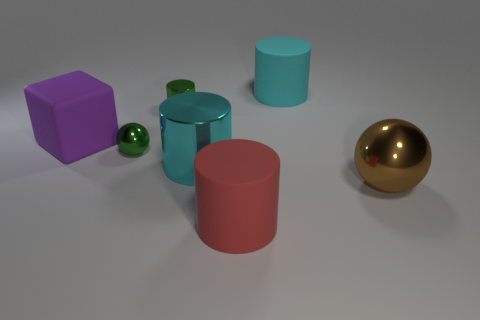There is a shiny ball that is left of the large cylinder behind the purple thing; how big is it?
Your response must be concise. Small. What is the color of the cylinder that is both behind the red thing and in front of the block?
Your answer should be very brief. Cyan. There is a red cylinder that is the same size as the matte cube; what is its material?
Make the answer very short. Rubber. What number of other objects are the same material as the big sphere?
Give a very brief answer. 3. Is the color of the small shiny thing that is in front of the tiny cylinder the same as the tiny thing that is behind the block?
Offer a very short reply. Yes. There is a tiny green object behind the large cube that is left of the big brown metallic ball; what is its shape?
Your response must be concise. Cylinder. How many other things are the same color as the large ball?
Give a very brief answer. 0. Is the cyan cylinder behind the large matte block made of the same material as the purple cube behind the brown metallic thing?
Provide a short and direct response. Yes. There is a ball that is behind the large cyan shiny thing; what size is it?
Ensure brevity in your answer.  Small. What is the material of the large red object that is the same shape as the cyan matte thing?
Offer a terse response. Rubber. 